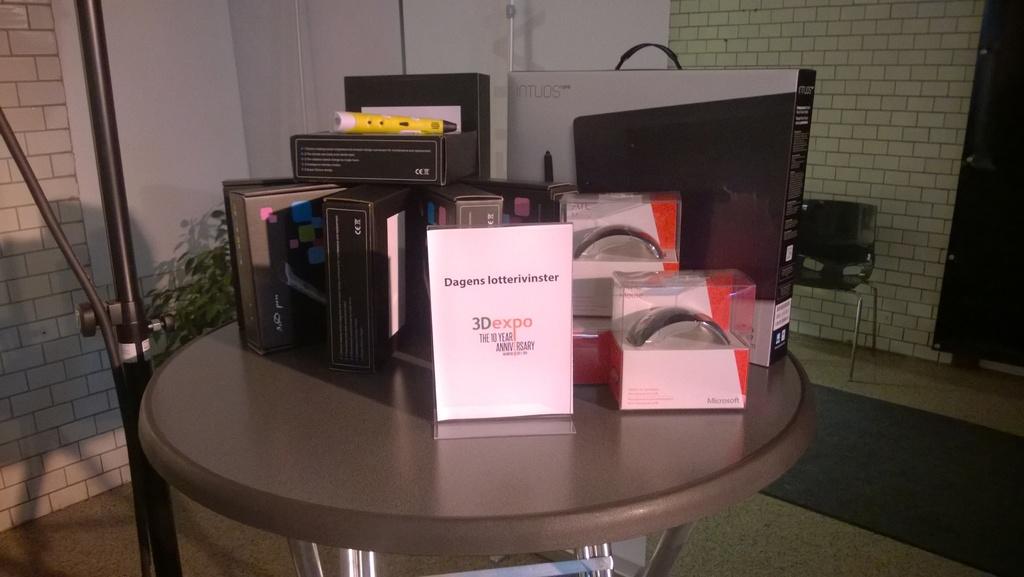What is written above 3dexpo?
Your response must be concise. Dagens lotterivinster. 